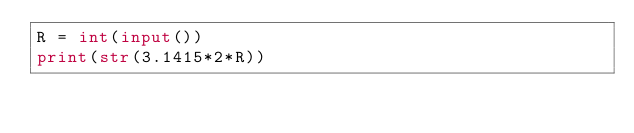Convert code to text. <code><loc_0><loc_0><loc_500><loc_500><_Python_>R = int(input())
print(str(3.1415*2*R))</code> 